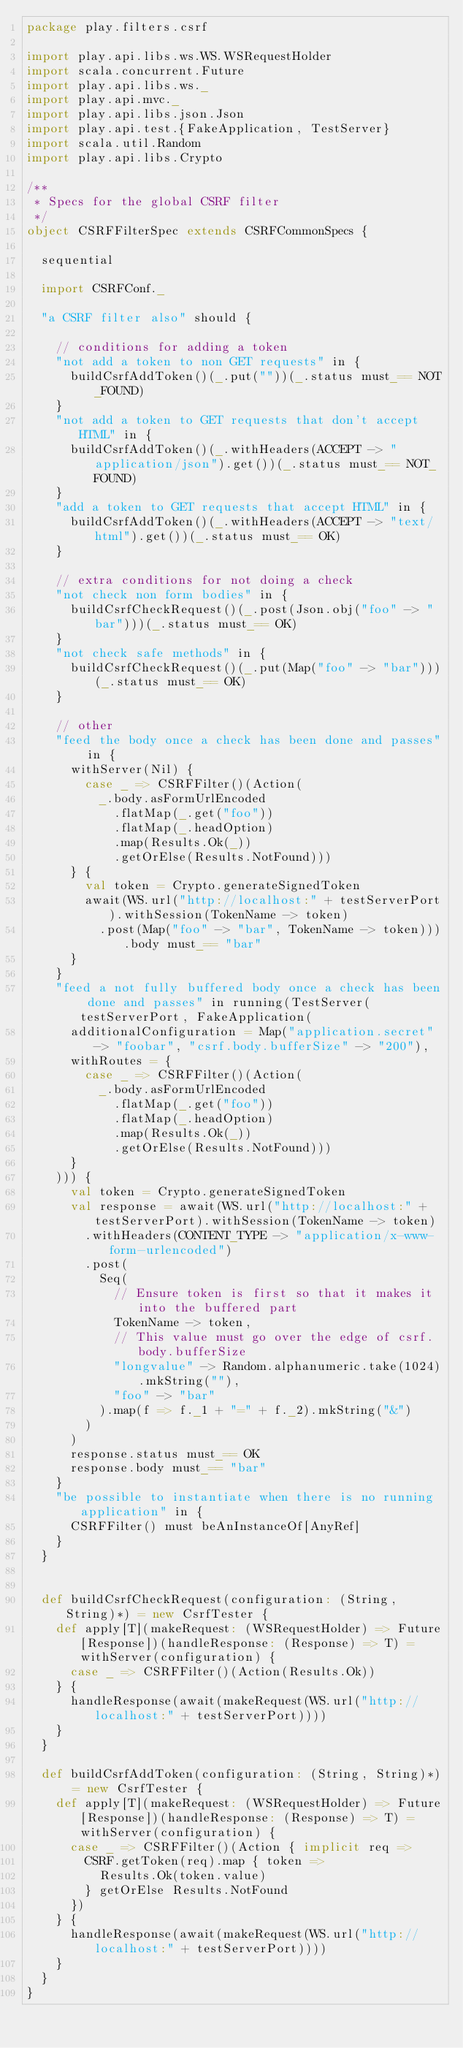Convert code to text. <code><loc_0><loc_0><loc_500><loc_500><_Scala_>package play.filters.csrf

import play.api.libs.ws.WS.WSRequestHolder
import scala.concurrent.Future
import play.api.libs.ws._
import play.api.mvc._
import play.api.libs.json.Json
import play.api.test.{FakeApplication, TestServer}
import scala.util.Random
import play.api.libs.Crypto

/**
 * Specs for the global CSRF filter
 */
object CSRFFilterSpec extends CSRFCommonSpecs {

  sequential

  import CSRFConf._

  "a CSRF filter also" should {

    // conditions for adding a token
    "not add a token to non GET requests" in {
      buildCsrfAddToken()(_.put(""))(_.status must_== NOT_FOUND)
    }
    "not add a token to GET requests that don't accept HTML" in {
      buildCsrfAddToken()(_.withHeaders(ACCEPT -> "application/json").get())(_.status must_== NOT_FOUND)
    }
    "add a token to GET requests that accept HTML" in {
      buildCsrfAddToken()(_.withHeaders(ACCEPT -> "text/html").get())(_.status must_== OK)
    }

    // extra conditions for not doing a check
    "not check non form bodies" in {
      buildCsrfCheckRequest()(_.post(Json.obj("foo" -> "bar")))(_.status must_== OK)
    }
    "not check safe methods" in {
      buildCsrfCheckRequest()(_.put(Map("foo" -> "bar")))(_.status must_== OK)
    }

    // other
    "feed the body once a check has been done and passes" in {
      withServer(Nil) {
        case _ => CSRFFilter()(Action(
          _.body.asFormUrlEncoded
            .flatMap(_.get("foo"))
            .flatMap(_.headOption)
            .map(Results.Ok(_))
            .getOrElse(Results.NotFound)))
      } {
        val token = Crypto.generateSignedToken
        await(WS.url("http://localhost:" + testServerPort).withSession(TokenName -> token)
          .post(Map("foo" -> "bar", TokenName -> token))).body must_== "bar"
      }
    }
    "feed a not fully buffered body once a check has been done and passes" in running(TestServer(testServerPort, FakeApplication(
      additionalConfiguration = Map("application.secret" -> "foobar", "csrf.body.bufferSize" -> "200"),
      withRoutes = {
        case _ => CSRFFilter()(Action(
          _.body.asFormUrlEncoded
            .flatMap(_.get("foo"))
            .flatMap(_.headOption)
            .map(Results.Ok(_))
            .getOrElse(Results.NotFound)))
      }
    ))) {
      val token = Crypto.generateSignedToken
      val response = await(WS.url("http://localhost:" + testServerPort).withSession(TokenName -> token)
        .withHeaders(CONTENT_TYPE -> "application/x-www-form-urlencoded")
        .post(
          Seq(
            // Ensure token is first so that it makes it into the buffered part
            TokenName -> token,
            // This value must go over the edge of csrf.body.bufferSize
            "longvalue" -> Random.alphanumeric.take(1024).mkString(""),
            "foo" -> "bar"
          ).map(f => f._1 + "=" + f._2).mkString("&")
        )
      )
      response.status must_== OK
      response.body must_== "bar"
    }
    "be possible to instantiate when there is no running application" in {
      CSRFFilter() must beAnInstanceOf[AnyRef]
    }
  }


  def buildCsrfCheckRequest(configuration: (String, String)*) = new CsrfTester {
    def apply[T](makeRequest: (WSRequestHolder) => Future[Response])(handleResponse: (Response) => T) = withServer(configuration) {
      case _ => CSRFFilter()(Action(Results.Ok))
    } {
      handleResponse(await(makeRequest(WS.url("http://localhost:" + testServerPort))))
    }
  }

  def buildCsrfAddToken(configuration: (String, String)*) = new CsrfTester {
    def apply[T](makeRequest: (WSRequestHolder) => Future[Response])(handleResponse: (Response) => T) = withServer(configuration) {
      case _ => CSRFFilter()(Action { implicit req =>
        CSRF.getToken(req).map { token =>
          Results.Ok(token.value)
        } getOrElse Results.NotFound
      })
    } {
      handleResponse(await(makeRequest(WS.url("http://localhost:" + testServerPort))))
    }
  }
}
</code> 